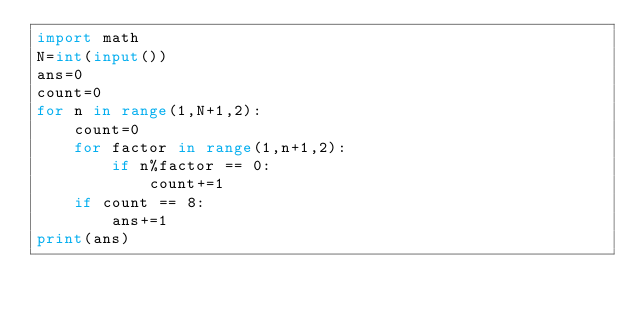Convert code to text. <code><loc_0><loc_0><loc_500><loc_500><_Python_>import math
N=int(input())
ans=0
count=0
for n in range(1,N+1,2):
	count=0
	for factor in range(1,n+1,2):
		if n%factor == 0:
			count+=1
	if count == 8:
		ans+=1
print(ans)</code> 